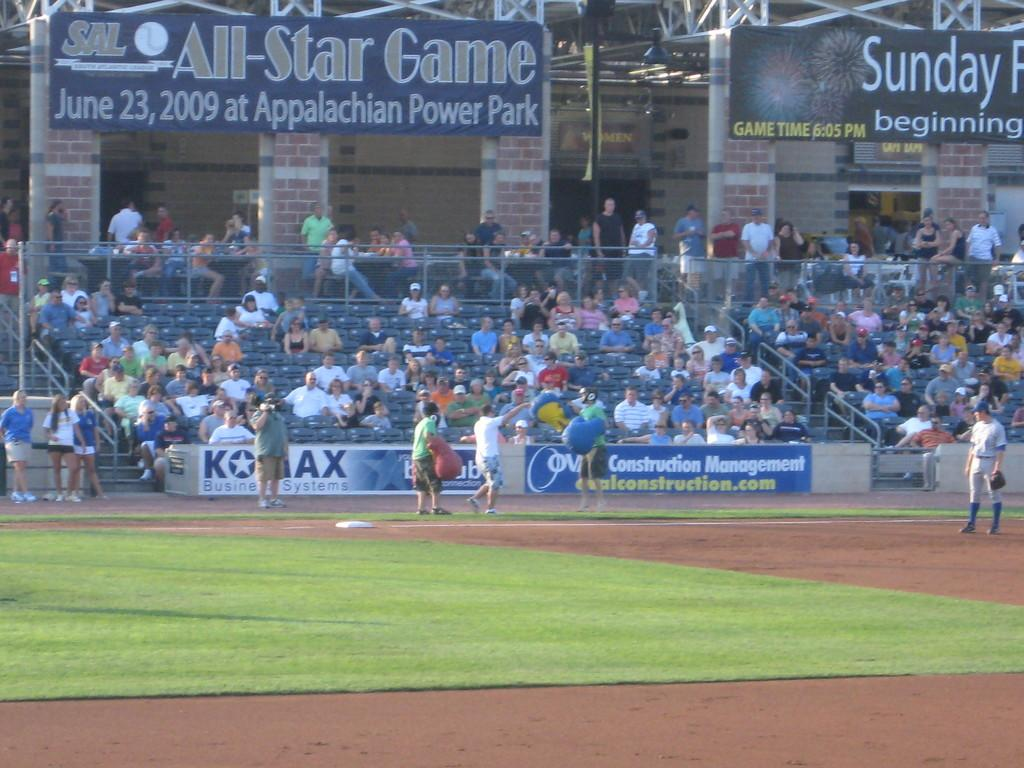<image>
Render a clear and concise summary of the photo. Two men at the edge of the Appalachian Power Park try to get the crowd going while a baseball player watches. 